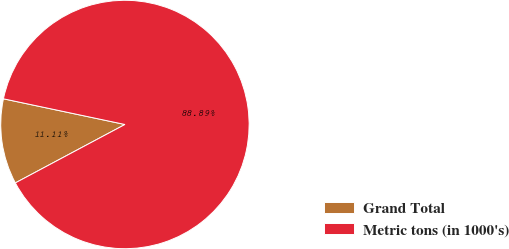Convert chart. <chart><loc_0><loc_0><loc_500><loc_500><pie_chart><fcel>Grand Total<fcel>Metric tons (in 1000's)<nl><fcel>11.11%<fcel>88.89%<nl></chart> 